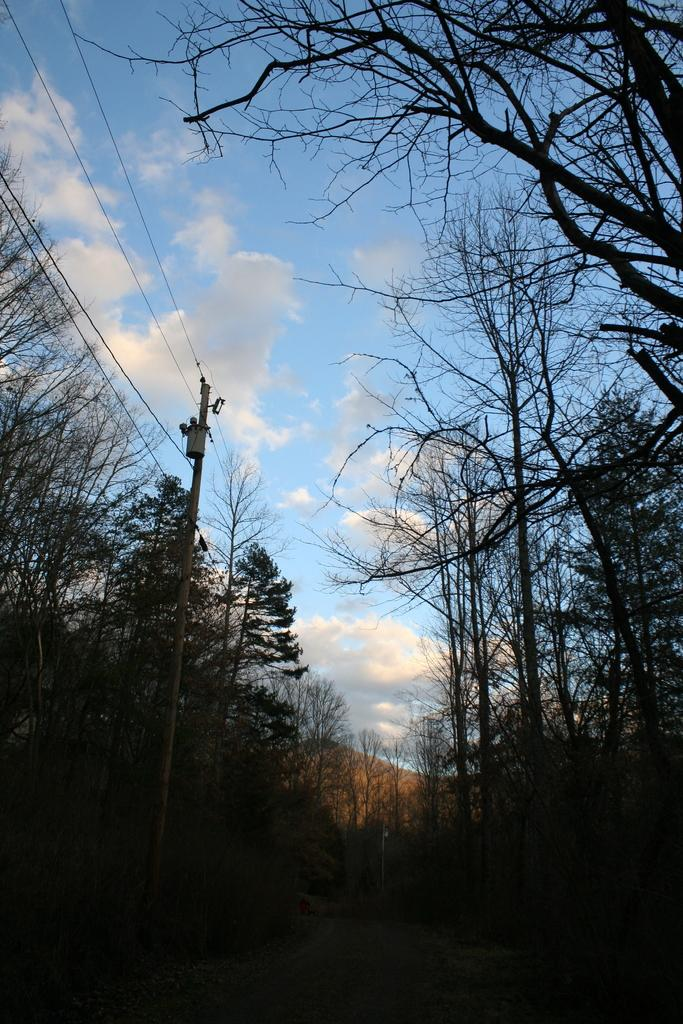What type of vegetation can be seen in the image? There are trees in the image. What else is present in the image besides trees? There is a pole with wires in the image. What can be seen in the background of the image? The sky is visible in the background of the image. What is the condition of the sky in the image? Clouds are present in the sky. What does the dad say about the mouth in the image? There is no mention of a dad or a mouth in the image; it only features trees, a pole with wires, and a sky with clouds. 